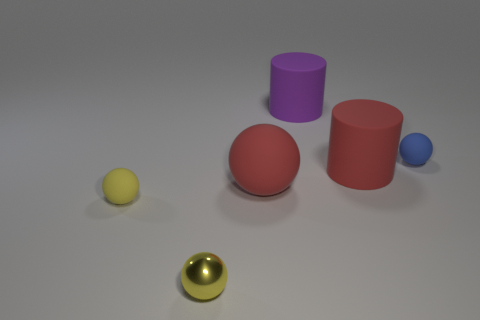Subtract all blue balls. How many balls are left? 3 Add 4 yellow rubber balls. How many objects exist? 10 Subtract all purple cylinders. How many cylinders are left? 1 Subtract all cyan balls. How many yellow cylinders are left? 0 Subtract all tiny metallic objects. Subtract all purple matte cylinders. How many objects are left? 4 Add 6 large red cylinders. How many large red cylinders are left? 7 Add 4 blue matte spheres. How many blue matte spheres exist? 5 Subtract 1 blue spheres. How many objects are left? 5 Subtract all cylinders. How many objects are left? 4 Subtract all cyan spheres. Subtract all gray cubes. How many spheres are left? 4 